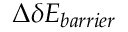Convert formula to latex. <formula><loc_0><loc_0><loc_500><loc_500>\Delta \delta E _ { b a r r i e r }</formula> 